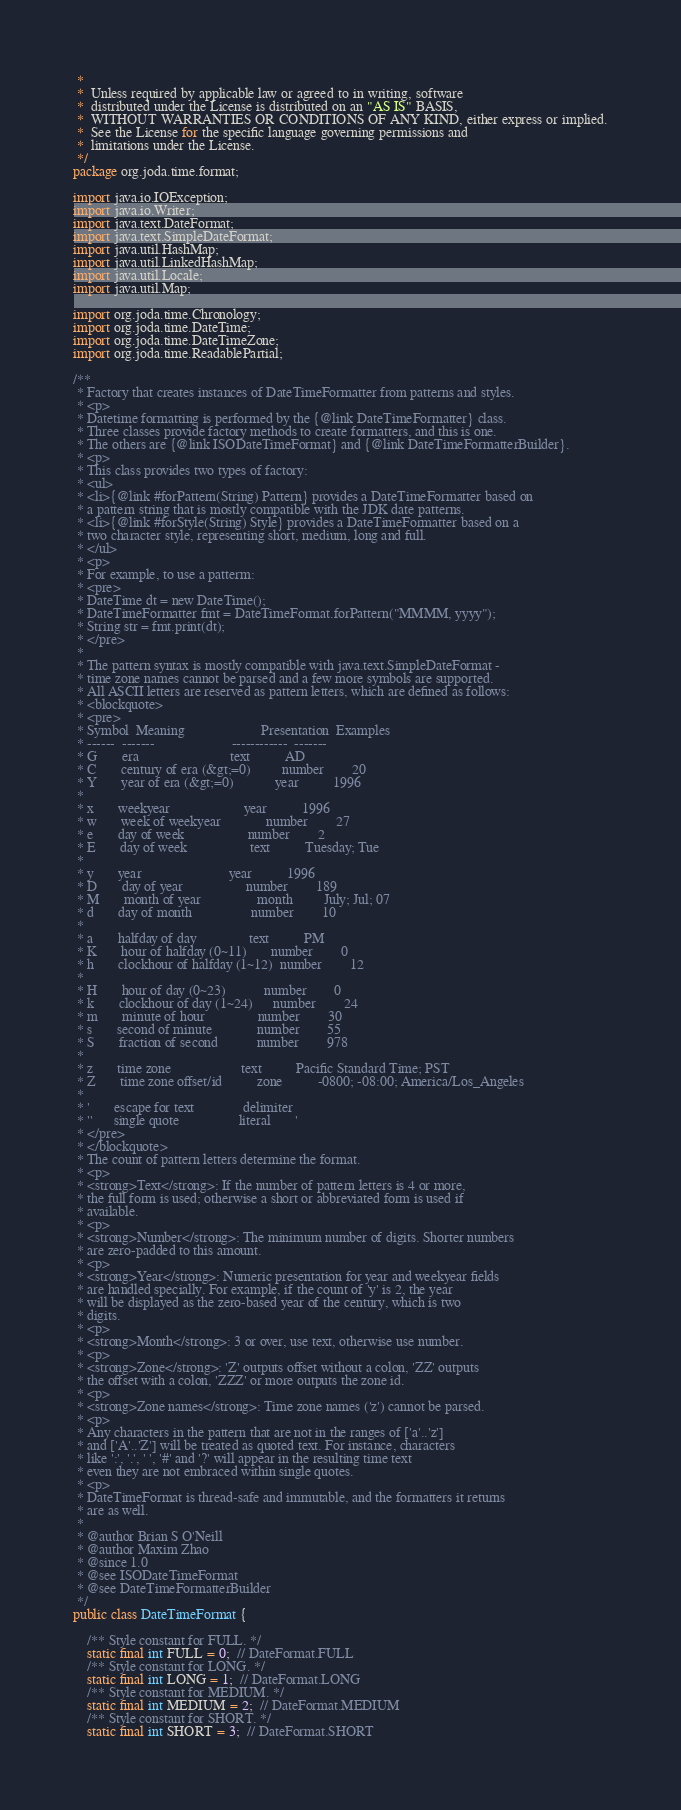<code> <loc_0><loc_0><loc_500><loc_500><_Java_> *
 *  Unless required by applicable law or agreed to in writing, software
 *  distributed under the License is distributed on an "AS IS" BASIS,
 *  WITHOUT WARRANTIES OR CONDITIONS OF ANY KIND, either express or implied.
 *  See the License for the specific language governing permissions and
 *  limitations under the License.
 */
package org.joda.time.format;

import java.io.IOException;
import java.io.Writer;
import java.text.DateFormat;
import java.text.SimpleDateFormat;
import java.util.HashMap;
import java.util.LinkedHashMap;
import java.util.Locale;
import java.util.Map;

import org.joda.time.Chronology;
import org.joda.time.DateTime;
import org.joda.time.DateTimeZone;
import org.joda.time.ReadablePartial;

/**
 * Factory that creates instances of DateTimeFormatter from patterns and styles.
 * <p>
 * Datetime formatting is performed by the {@link DateTimeFormatter} class.
 * Three classes provide factory methods to create formatters, and this is one.
 * The others are {@link ISODateTimeFormat} and {@link DateTimeFormatterBuilder}.
 * <p>
 * This class provides two types of factory:
 * <ul>
 * <li>{@link #forPattern(String) Pattern} provides a DateTimeFormatter based on
 * a pattern string that is mostly compatible with the JDK date patterns.
 * <li>{@link #forStyle(String) Style} provides a DateTimeFormatter based on a
 * two character style, representing short, medium, long and full.
 * </ul>
 * <p>
 * For example, to use a patterm:
 * <pre>
 * DateTime dt = new DateTime();
 * DateTimeFormatter fmt = DateTimeFormat.forPattern("MMMM, yyyy");
 * String str = fmt.print(dt);
 * </pre>
 *
 * The pattern syntax is mostly compatible with java.text.SimpleDateFormat -
 * time zone names cannot be parsed and a few more symbols are supported.
 * All ASCII letters are reserved as pattern letters, which are defined as follows:
 * <blockquote>
 * <pre>
 * Symbol  Meaning                      Presentation  Examples
 * ------  -------                      ------------  -------
 * G       era                          text          AD
 * C       century of era (&gt;=0)         number        20
 * Y       year of era (&gt;=0)            year          1996
 *
 * x       weekyear                     year          1996
 * w       week of weekyear             number        27
 * e       day of week                  number        2
 * E       day of week                  text          Tuesday; Tue
 *
 * y       year                         year          1996
 * D       day of year                  number        189
 * M       month of year                month         July; Jul; 07
 * d       day of month                 number        10
 *
 * a       halfday of day               text          PM
 * K       hour of halfday (0~11)       number        0
 * h       clockhour of halfday (1~12)  number        12
 *
 * H       hour of day (0~23)           number        0
 * k       clockhour of day (1~24)      number        24
 * m       minute of hour               number        30
 * s       second of minute             number        55
 * S       fraction of second           number        978
 *
 * z       time zone                    text          Pacific Standard Time; PST
 * Z       time zone offset/id          zone          -0800; -08:00; America/Los_Angeles
 *
 * '       escape for text              delimiter
 * ''      single quote                 literal       '
 * </pre>
 * </blockquote>
 * The count of pattern letters determine the format.
 * <p>
 * <strong>Text</strong>: If the number of pattern letters is 4 or more,
 * the full form is used; otherwise a short or abbreviated form is used if
 * available.
 * <p>
 * <strong>Number</strong>: The minimum number of digits. Shorter numbers
 * are zero-padded to this amount.
 * <p>
 * <strong>Year</strong>: Numeric presentation for year and weekyear fields
 * are handled specially. For example, if the count of 'y' is 2, the year
 * will be displayed as the zero-based year of the century, which is two
 * digits.
 * <p>
 * <strong>Month</strong>: 3 or over, use text, otherwise use number.
 * <p>
 * <strong>Zone</strong>: 'Z' outputs offset without a colon, 'ZZ' outputs
 * the offset with a colon, 'ZZZ' or more outputs the zone id.
 * <p>
 * <strong>Zone names</strong>: Time zone names ('z') cannot be parsed.
 * <p>
 * Any characters in the pattern that are not in the ranges of ['a'..'z']
 * and ['A'..'Z'] will be treated as quoted text. For instance, characters
 * like ':', '.', ' ', '#' and '?' will appear in the resulting time text
 * even they are not embraced within single quotes.
 * <p>
 * DateTimeFormat is thread-safe and immutable, and the formatters it returns
 * are as well.
 *
 * @author Brian S O'Neill
 * @author Maxim Zhao
 * @since 1.0
 * @see ISODateTimeFormat
 * @see DateTimeFormatterBuilder
 */
public class DateTimeFormat {

    /** Style constant for FULL. */
    static final int FULL = 0;  // DateFormat.FULL
    /** Style constant for LONG. */
    static final int LONG = 1;  // DateFormat.LONG
    /** Style constant for MEDIUM. */
    static final int MEDIUM = 2;  // DateFormat.MEDIUM
    /** Style constant for SHORT. */
    static final int SHORT = 3;  // DateFormat.SHORT</code> 